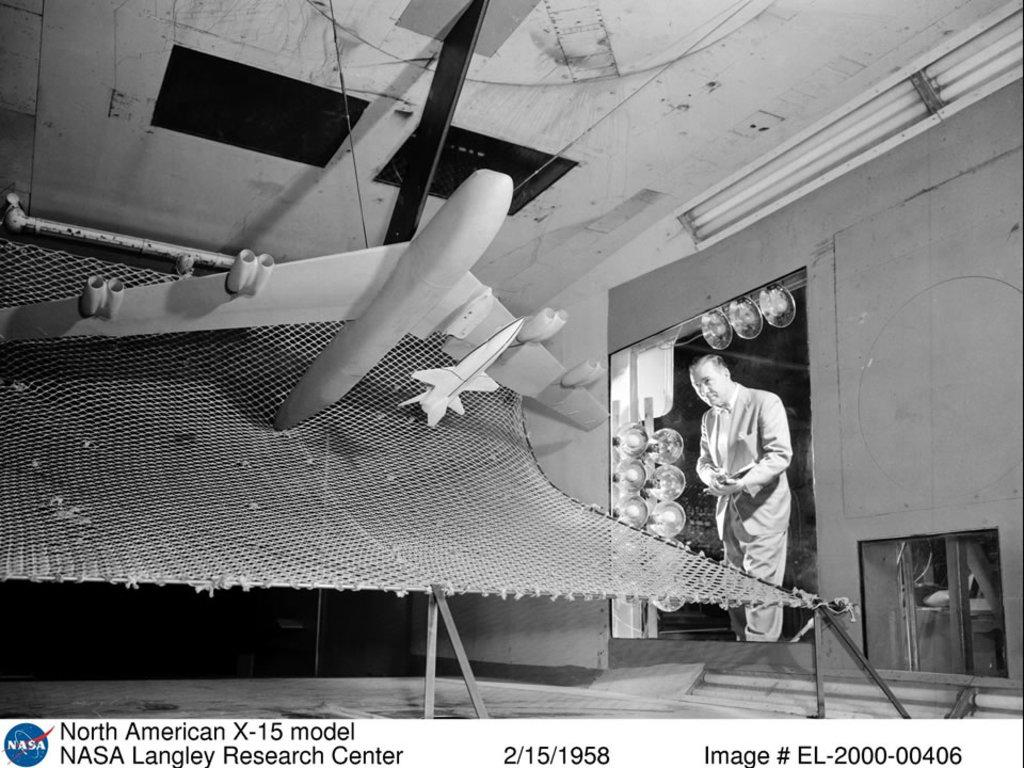Provide a one-sentence caption for the provided image. Airplane model from Nasa dated on 2/15/1958 that includes image # EL-2000-00406. 